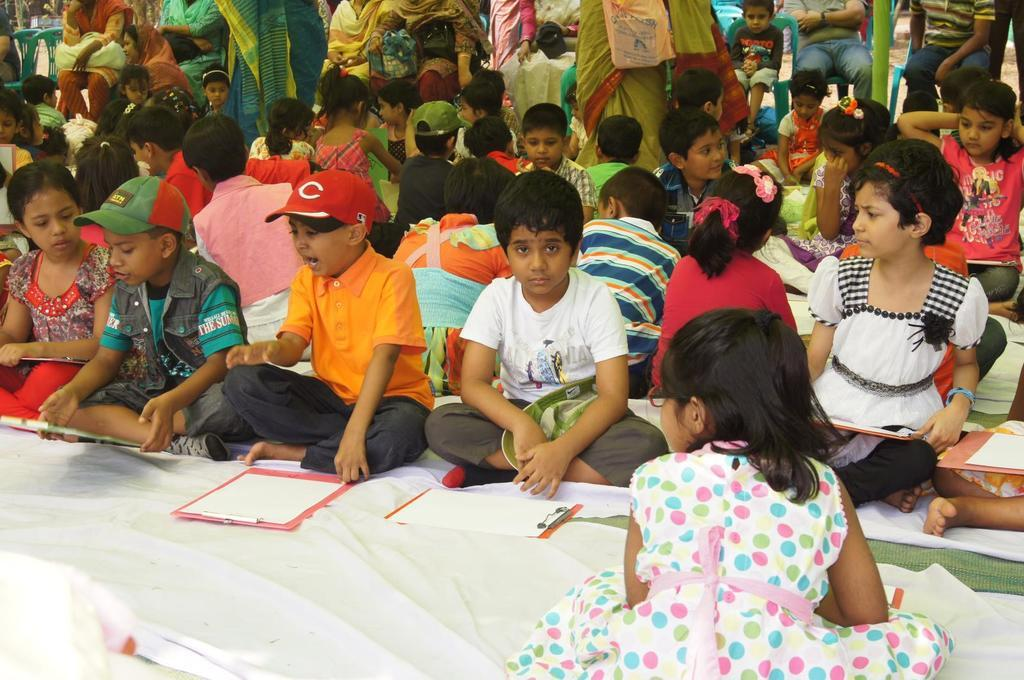What are the children doing in the image? The children are seated on the floor. What objects are in front of the children? There are papers on a writing pad in front of the children. Who is standing behind the children? There are women standing behind the children. What type of vacation is the group planning in the image? There is no indication of a vacation in the image; the children are seated on the floor with papers in front of them, and women are standing behind them. 